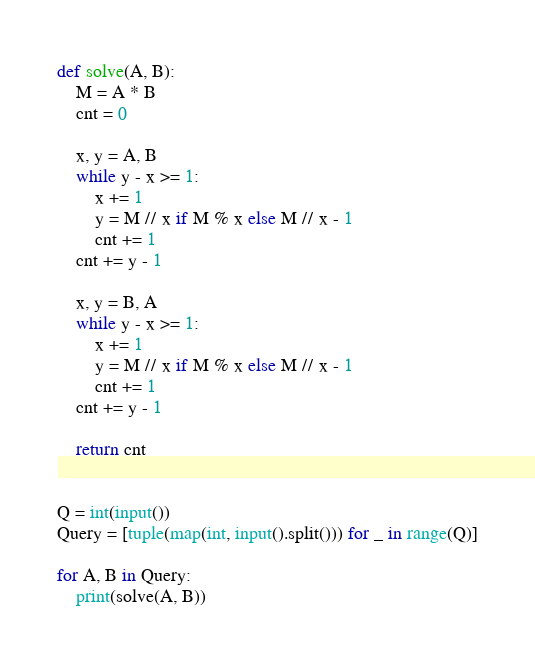Convert code to text. <code><loc_0><loc_0><loc_500><loc_500><_Python_>def solve(A, B):
    M = A * B
    cnt = 0

    x, y = A, B
    while y - x >= 1:
        x += 1
        y = M // x if M % x else M // x - 1
        cnt += 1
    cnt += y - 1

    x, y = B, A
    while y - x >= 1:
        x += 1
        y = M // x if M % x else M // x - 1
        cnt += 1
    cnt += y - 1

    return cnt


Q = int(input())
Query = [tuple(map(int, input().split())) for _ in range(Q)]

for A, B in Query:
    print(solve(A, B))
</code> 